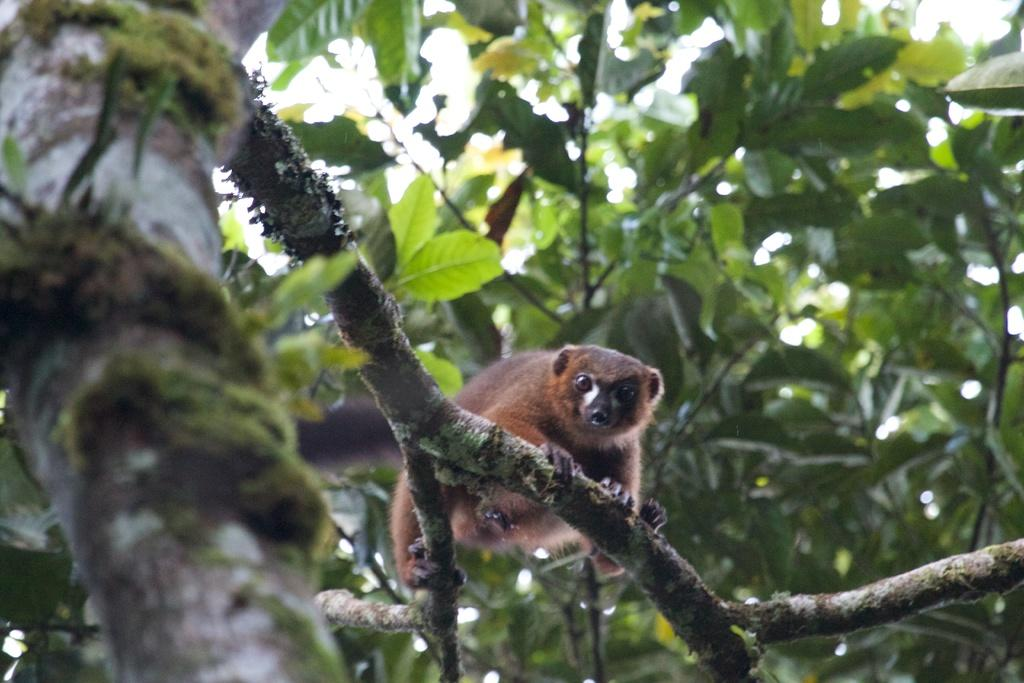What is on the tree branch in the image? There is an animal on a tree branch in the image. What can be seen in the background of the image? There are leaves visible in the background of the image. What type of quiver is the animal using to store its arrows in the image? There is no quiver or arrows present in the image; it features an animal on a tree branch and leaves in the background. 